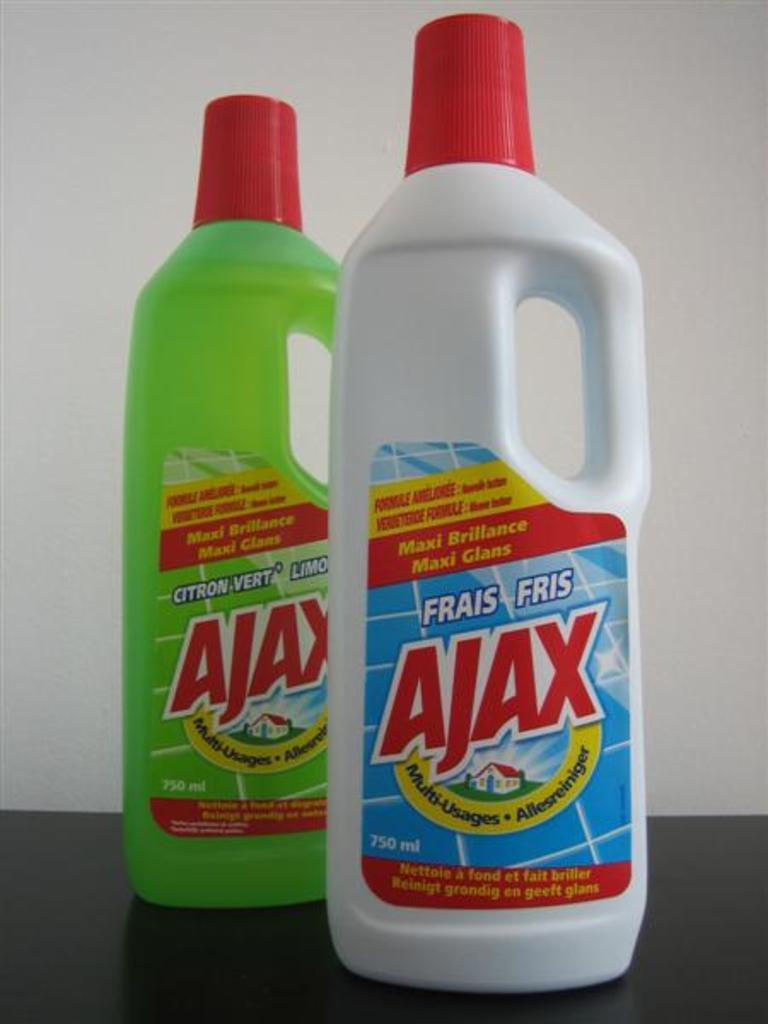How would you summarize this image in a sentence or two? There are two bottles. Which are in green and white color. On the background there is a wall. 